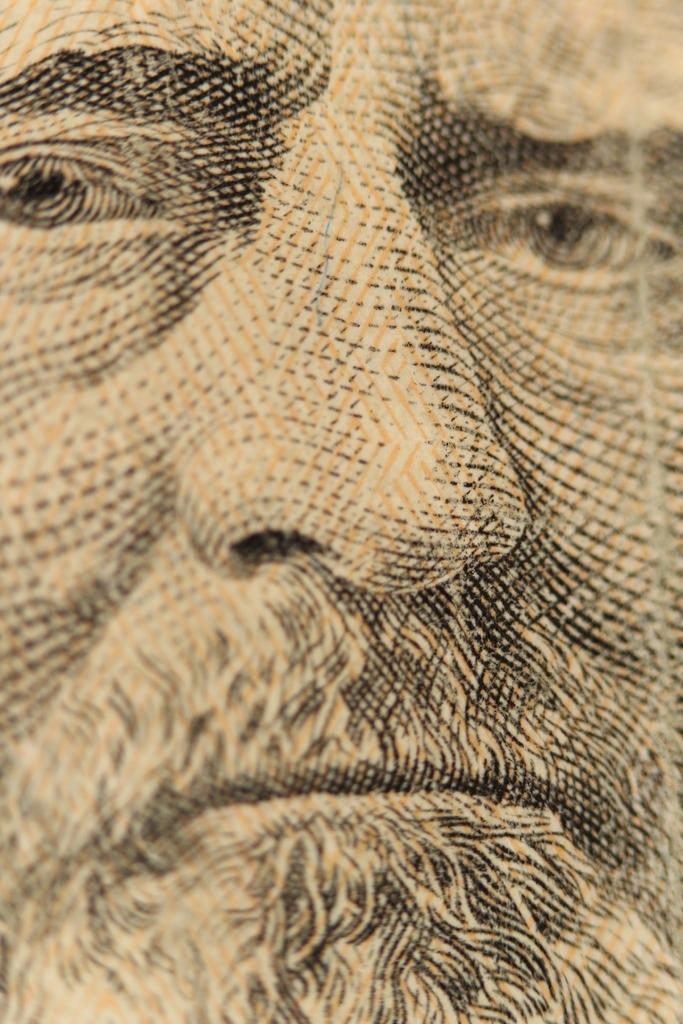What is the main subject of the image? There is a painting of a man in the image. Where can the geese be found in the image? There are no geese present in the image; it features a painting of a man. What type of ocean is depicted in the image? There is no ocean depicted in the image; it features a painting of a man. 